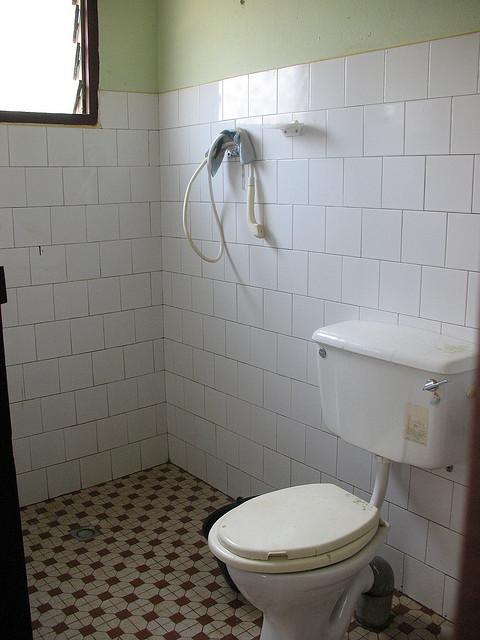Is this a working toilet?
Be succinct. Yes. Is the window open?
Answer briefly. Yes. Is the light on?
Give a very brief answer. No. Is there any tile in the bathroom?
Give a very brief answer. Yes. 